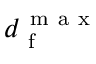<formula> <loc_0><loc_0><loc_500><loc_500>d _ { f } ^ { m a x }</formula> 